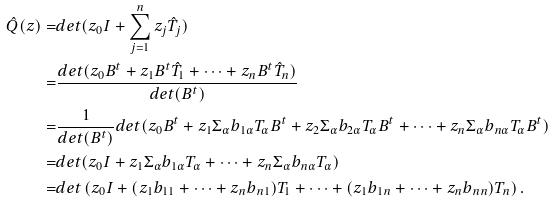Convert formula to latex. <formula><loc_0><loc_0><loc_500><loc_500>\hat { Q } ( z ) = & d e t ( z _ { 0 } I + \sum _ { j = 1 } ^ { n } z _ { j } \hat { T } _ { j } ) \\ = & \frac { d e t ( z _ { 0 } B ^ { t } + z _ { 1 } B ^ { t } \hat { T } _ { 1 } + \cdots + z _ { n } B ^ { t } \hat { T } _ { n } ) } { d e t ( B ^ { t } ) } \\ = & \frac { 1 } { d e t ( B ^ { t } ) } d e t ( z _ { 0 } B ^ { t } + z _ { 1 } \Sigma _ { \alpha } b _ { 1 \alpha } { T } _ { \alpha } B ^ { t } + z _ { 2 } \Sigma _ { \alpha } b _ { 2 \alpha } T _ { \alpha } B ^ { t } + \cdots + z _ { n } \Sigma _ { \alpha } b _ { n \alpha } T _ { \alpha } B ^ { t } ) \\ = & d e t ( z _ { 0 } I + z _ { 1 } \Sigma _ { \alpha } b _ { 1 \alpha } T _ { \alpha } + \cdots + z _ { n } \Sigma _ { \alpha } b _ { n \alpha } T _ { \alpha } ) \\ = & d e t \left ( z _ { 0 } I + ( z _ { 1 } b _ { 1 1 } + \cdots + z _ { n } b _ { n 1 } ) T _ { 1 } + \cdots + ( z _ { 1 } b _ { 1 n } + \cdots + z _ { n } b _ { n n } ) T _ { n } \right ) .</formula> 